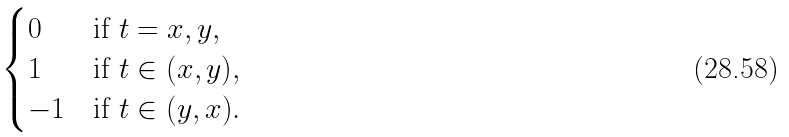<formula> <loc_0><loc_0><loc_500><loc_500>\begin{cases} 0 & \text {if $t=x,y$} , \\ 1 & \text {if $t\in(x,y)$} , \\ - 1 & \text {if $t\in(y,x)$} . \end{cases}</formula> 